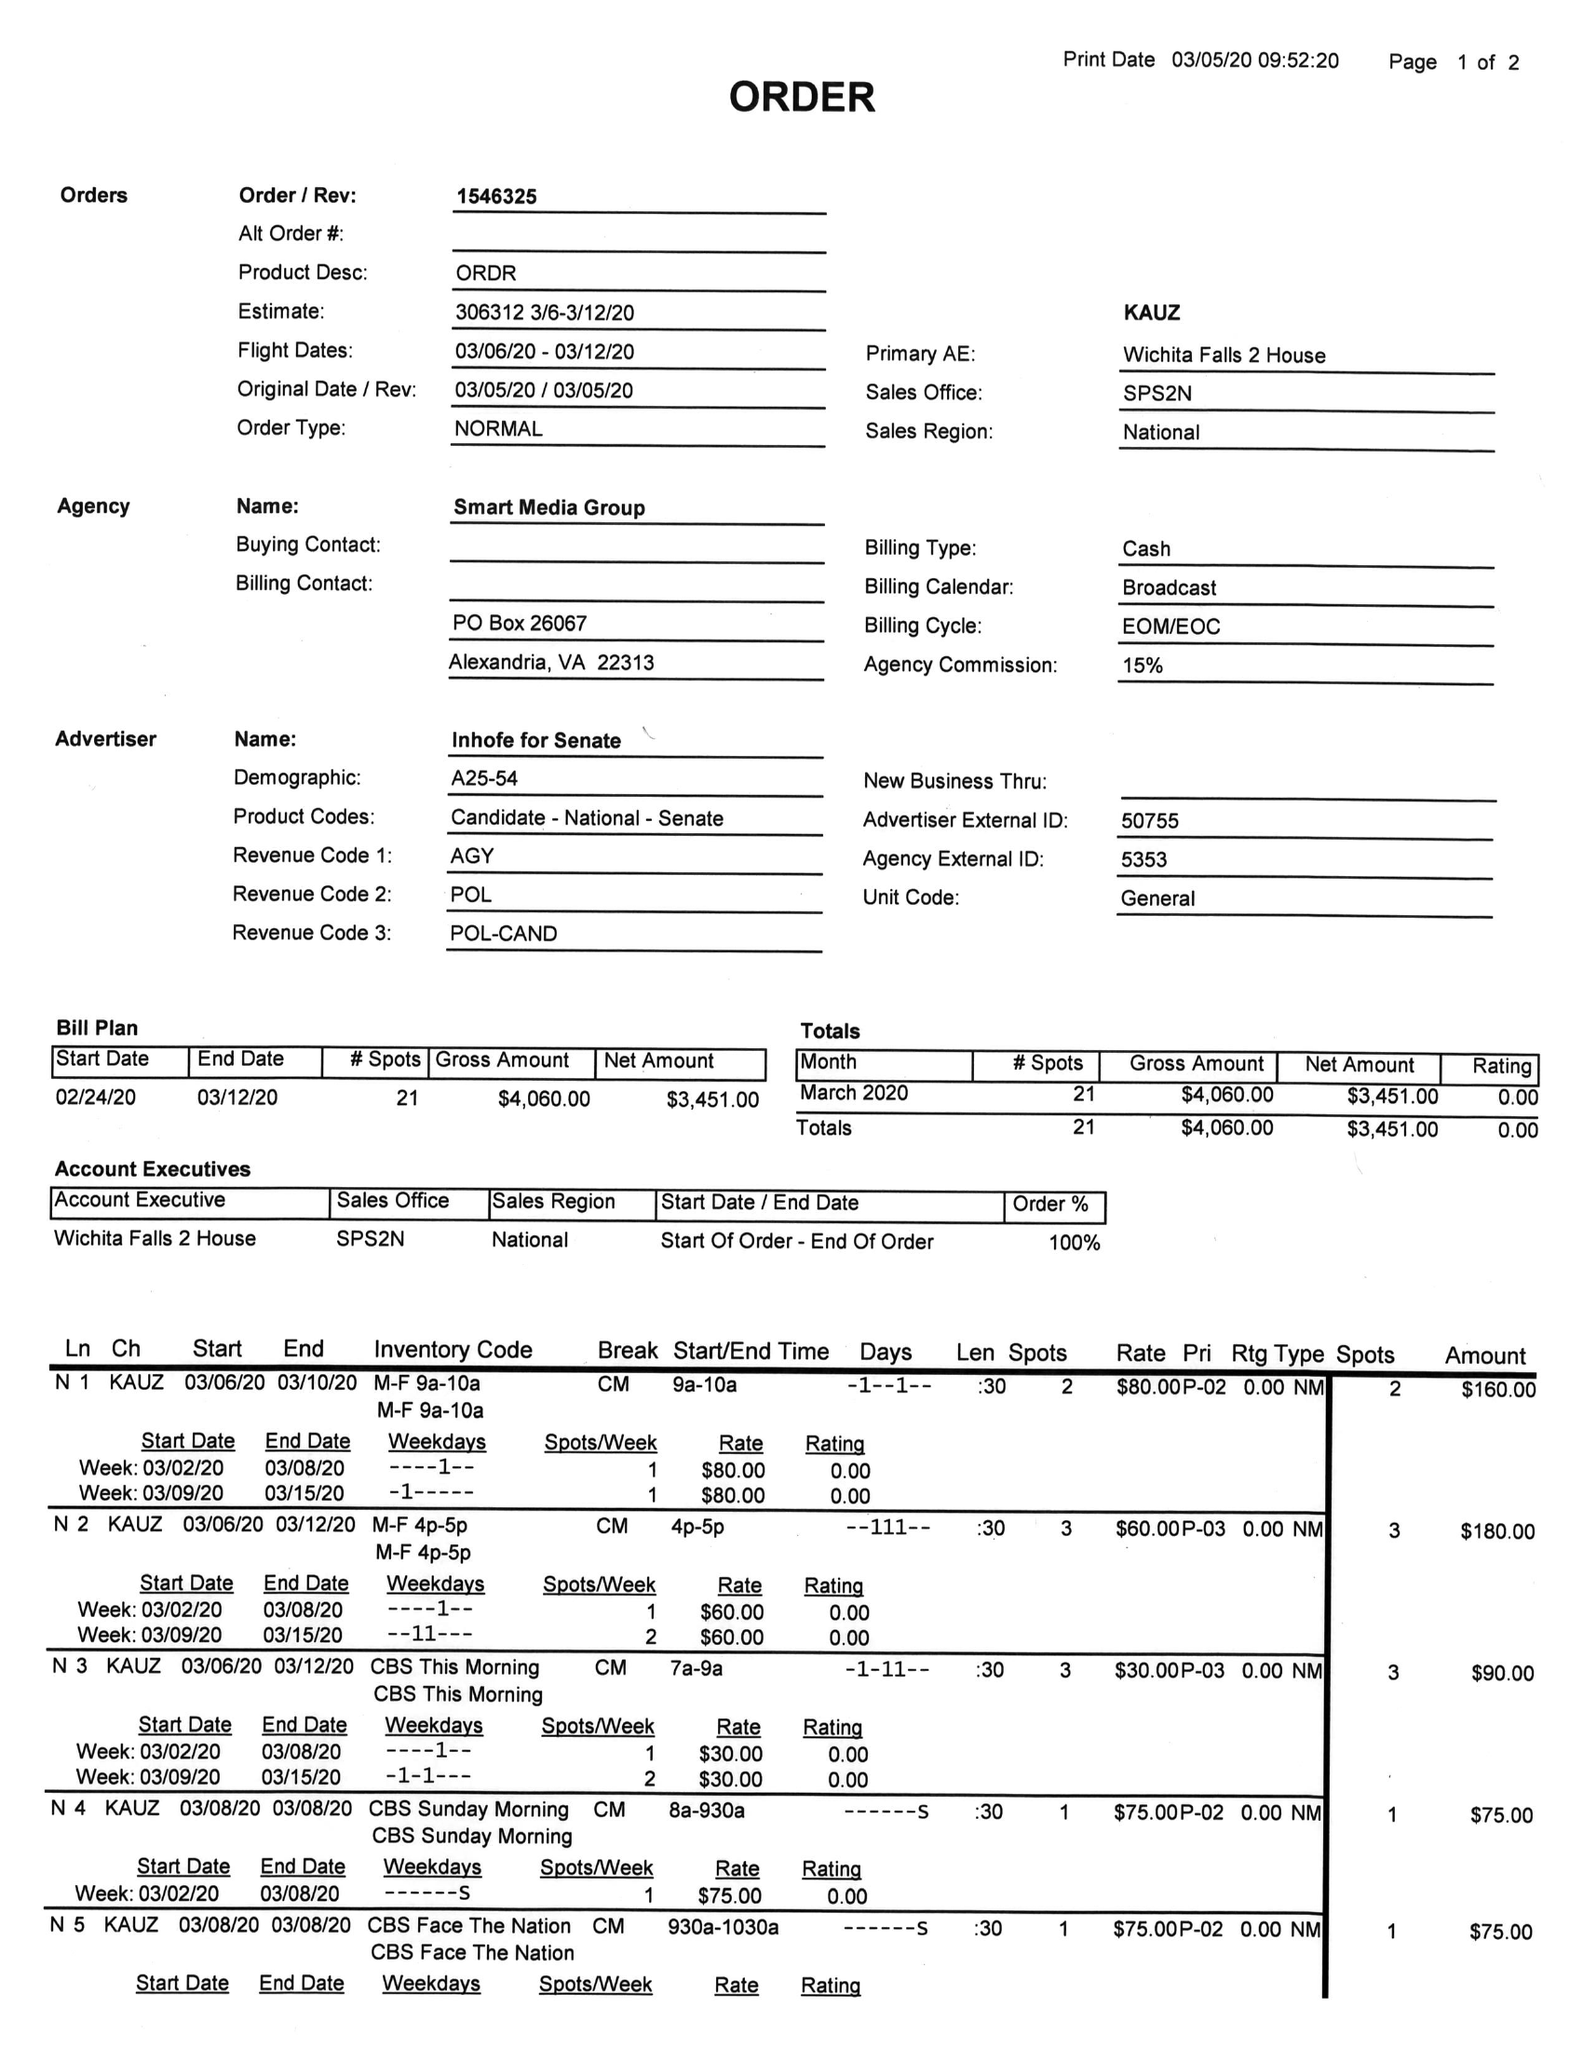What is the value for the gross_amount?
Answer the question using a single word or phrase. 4060.00 